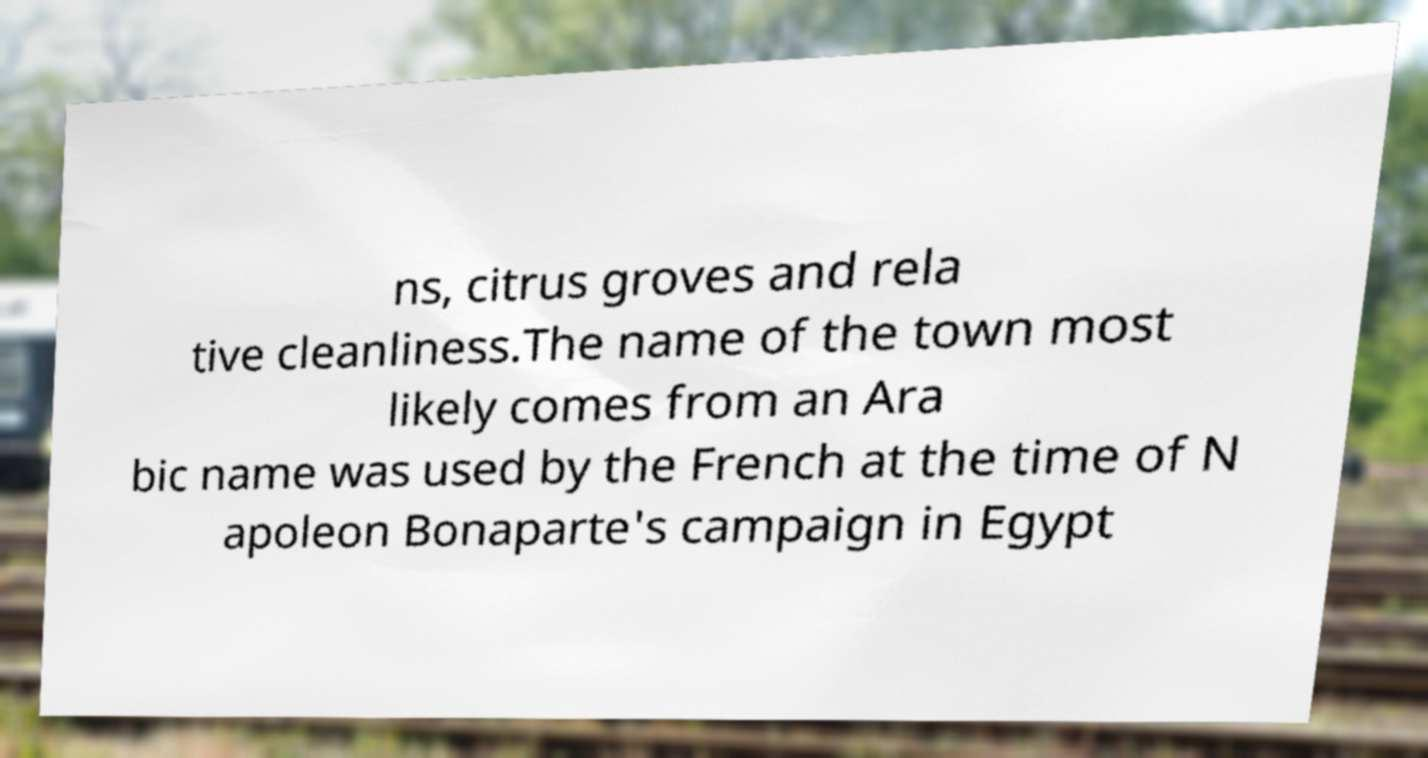Please read and relay the text visible in this image. What does it say? ns, citrus groves and rela tive cleanliness.The name of the town most likely comes from an Ara bic name was used by the French at the time of N apoleon Bonaparte's campaign in Egypt 